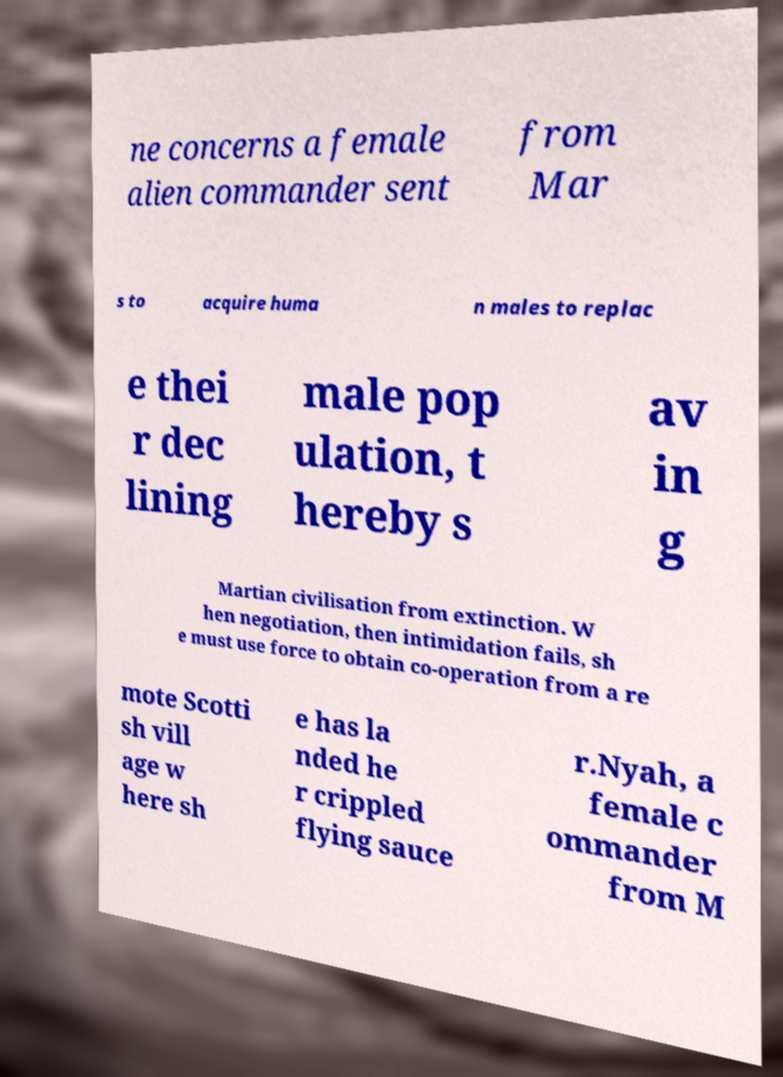Can you read and provide the text displayed in the image?This photo seems to have some interesting text. Can you extract and type it out for me? ne concerns a female alien commander sent from Mar s to acquire huma n males to replac e thei r dec lining male pop ulation, t hereby s av in g Martian civilisation from extinction. W hen negotiation, then intimidation fails, sh e must use force to obtain co-operation from a re mote Scotti sh vill age w here sh e has la nded he r crippled flying sauce r.Nyah, a female c ommander from M 